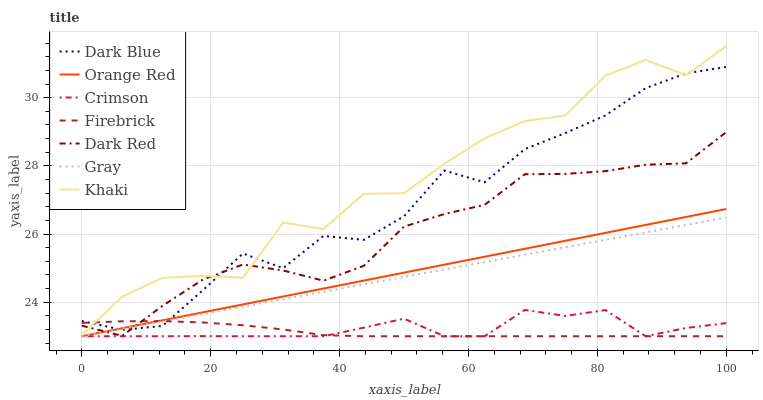Does Firebrick have the minimum area under the curve?
Answer yes or no. Yes. Does Khaki have the maximum area under the curve?
Answer yes or no. Yes. Does Dark Red have the minimum area under the curve?
Answer yes or no. No. Does Dark Red have the maximum area under the curve?
Answer yes or no. No. Is Gray the smoothest?
Answer yes or no. Yes. Is Khaki the roughest?
Answer yes or no. Yes. Is Dark Red the smoothest?
Answer yes or no. No. Is Dark Red the roughest?
Answer yes or no. No. Does Khaki have the lowest value?
Answer yes or no. No. Does Khaki have the highest value?
Answer yes or no. Yes. Does Dark Red have the highest value?
Answer yes or no. No. Is Crimson less than Dark Red?
Answer yes or no. Yes. Is Khaki greater than Crimson?
Answer yes or no. Yes. Does Gray intersect Dark Red?
Answer yes or no. Yes. Is Gray less than Dark Red?
Answer yes or no. No. Is Gray greater than Dark Red?
Answer yes or no. No. Does Crimson intersect Dark Red?
Answer yes or no. No. 